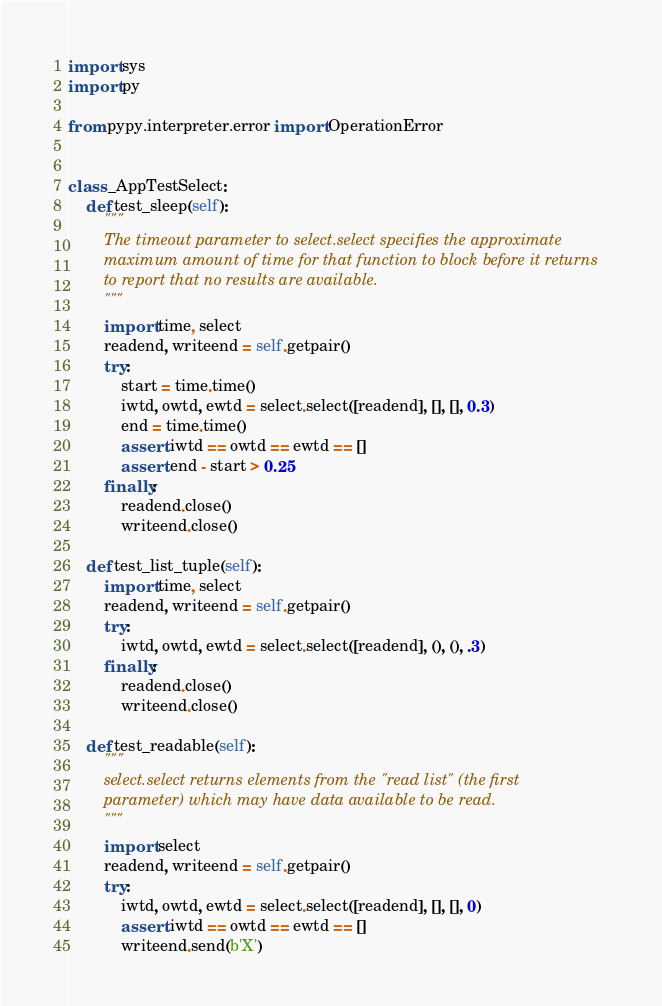<code> <loc_0><loc_0><loc_500><loc_500><_Python_>import sys
import py

from pypy.interpreter.error import OperationError


class _AppTestSelect:
    def test_sleep(self):
        """
        The timeout parameter to select.select specifies the approximate
        maximum amount of time for that function to block before it returns
        to report that no results are available.
        """
        import time, select
        readend, writeend = self.getpair()
        try:
            start = time.time()
            iwtd, owtd, ewtd = select.select([readend], [], [], 0.3)
            end = time.time()
            assert iwtd == owtd == ewtd == []
            assert end - start > 0.25
        finally:
            readend.close()
            writeend.close()

    def test_list_tuple(self):
        import time, select
        readend, writeend = self.getpair()
        try:
            iwtd, owtd, ewtd = select.select([readend], (), (), .3)
        finally:
            readend.close()
            writeend.close()

    def test_readable(self):
        """
        select.select returns elements from the "read list" (the first
        parameter) which may have data available to be read.
        """
        import select
        readend, writeend = self.getpair()
        try:
            iwtd, owtd, ewtd = select.select([readend], [], [], 0)
            assert iwtd == owtd == ewtd == []
            writeend.send(b'X')</code> 